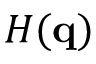<formula> <loc_0><loc_0><loc_500><loc_500>H ( q )</formula> 